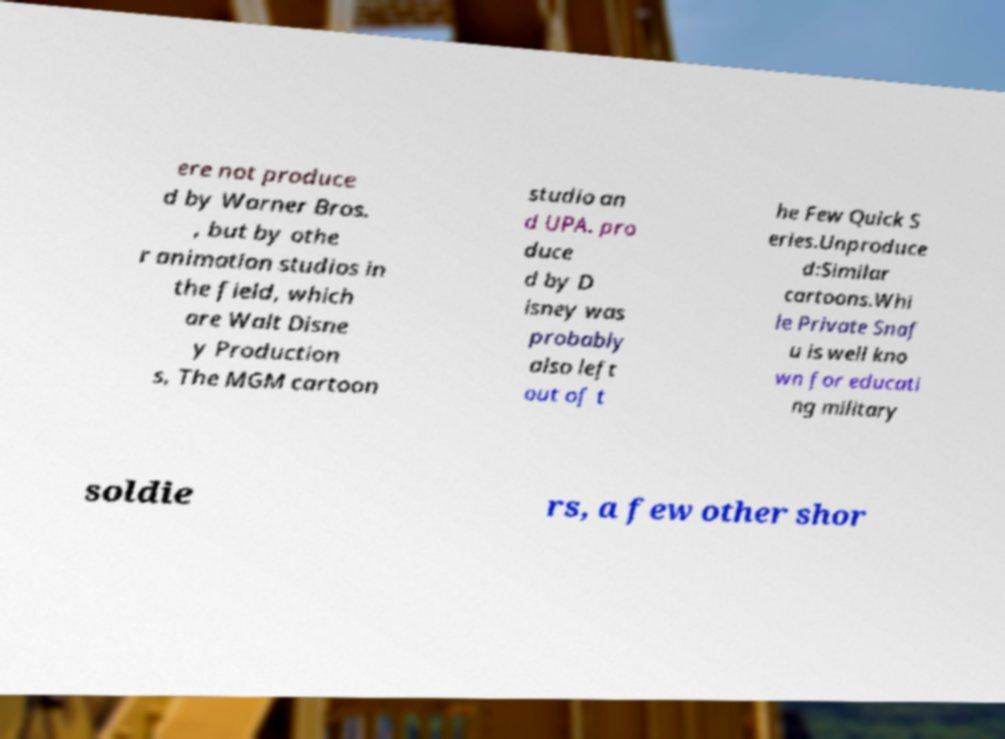Could you extract and type out the text from this image? ere not produce d by Warner Bros. , but by othe r animation studios in the field, which are Walt Disne y Production s, The MGM cartoon studio an d UPA. pro duce d by D isney was probably also left out of t he Few Quick S eries.Unproduce d:Similar cartoons.Whi le Private Snaf u is well kno wn for educati ng military soldie rs, a few other shor 